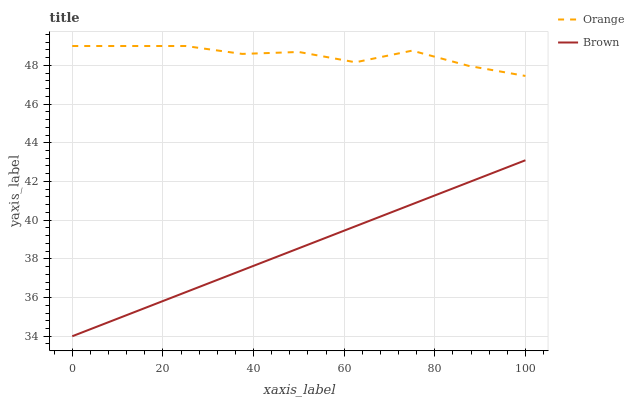Does Brown have the minimum area under the curve?
Answer yes or no. Yes. Does Orange have the maximum area under the curve?
Answer yes or no. Yes. Does Brown have the maximum area under the curve?
Answer yes or no. No. Is Brown the smoothest?
Answer yes or no. Yes. Is Orange the roughest?
Answer yes or no. Yes. Is Brown the roughest?
Answer yes or no. No. Does Brown have the lowest value?
Answer yes or no. Yes. Does Orange have the highest value?
Answer yes or no. Yes. Does Brown have the highest value?
Answer yes or no. No. Is Brown less than Orange?
Answer yes or no. Yes. Is Orange greater than Brown?
Answer yes or no. Yes. Does Brown intersect Orange?
Answer yes or no. No. 